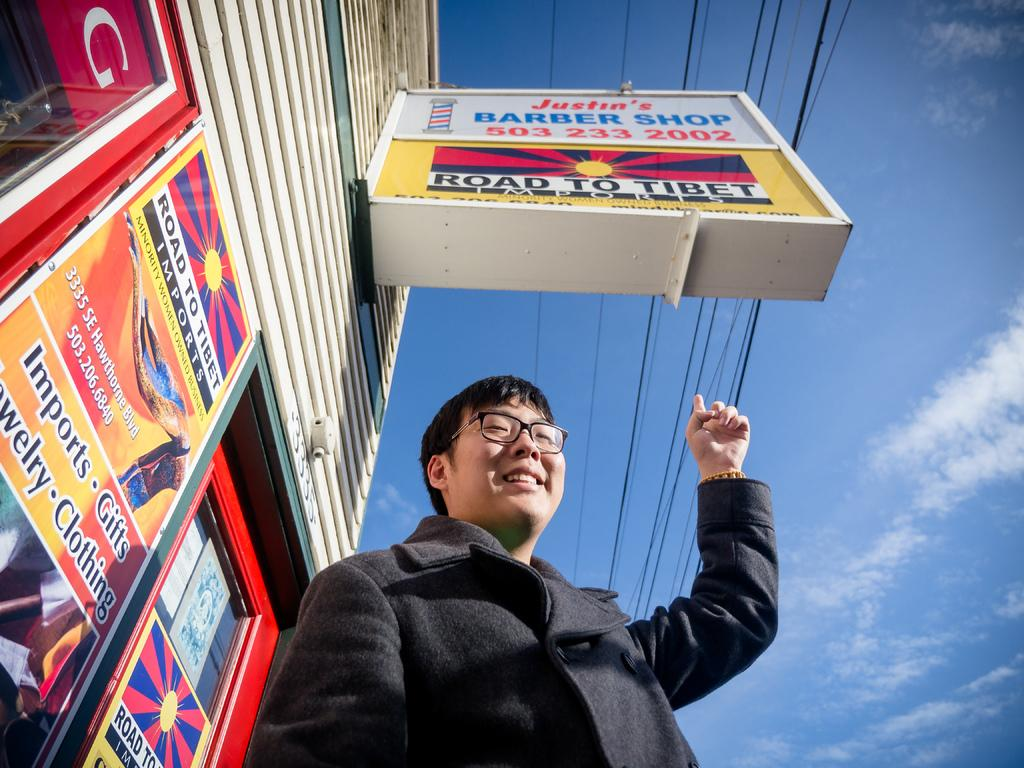<image>
Offer a succinct explanation of the picture presented. An Asian man standing under and pointing at the sign to Justin's Barber Shop. 